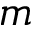Convert formula to latex. <formula><loc_0><loc_0><loc_500><loc_500>m</formula> 